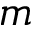Convert formula to latex. <formula><loc_0><loc_0><loc_500><loc_500>m</formula> 